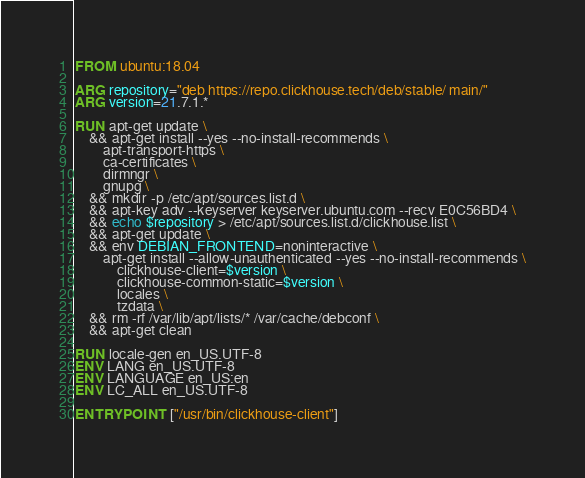<code> <loc_0><loc_0><loc_500><loc_500><_Dockerfile_>FROM ubuntu:18.04

ARG repository="deb https://repo.clickhouse.tech/deb/stable/ main/"
ARG version=21.7.1.*

RUN apt-get update \
    && apt-get install --yes --no-install-recommends \
        apt-transport-https \
        ca-certificates \
        dirmngr \
        gnupg \
    && mkdir -p /etc/apt/sources.list.d \
    && apt-key adv --keyserver keyserver.ubuntu.com --recv E0C56BD4 \
    && echo $repository > /etc/apt/sources.list.d/clickhouse.list \
    && apt-get update \
    && env DEBIAN_FRONTEND=noninteractive \
        apt-get install --allow-unauthenticated --yes --no-install-recommends \
            clickhouse-client=$version \
            clickhouse-common-static=$version \
            locales \
            tzdata \
    && rm -rf /var/lib/apt/lists/* /var/cache/debconf \
    && apt-get clean

RUN locale-gen en_US.UTF-8
ENV LANG en_US.UTF-8
ENV LANGUAGE en_US:en
ENV LC_ALL en_US.UTF-8

ENTRYPOINT ["/usr/bin/clickhouse-client"]
</code> 